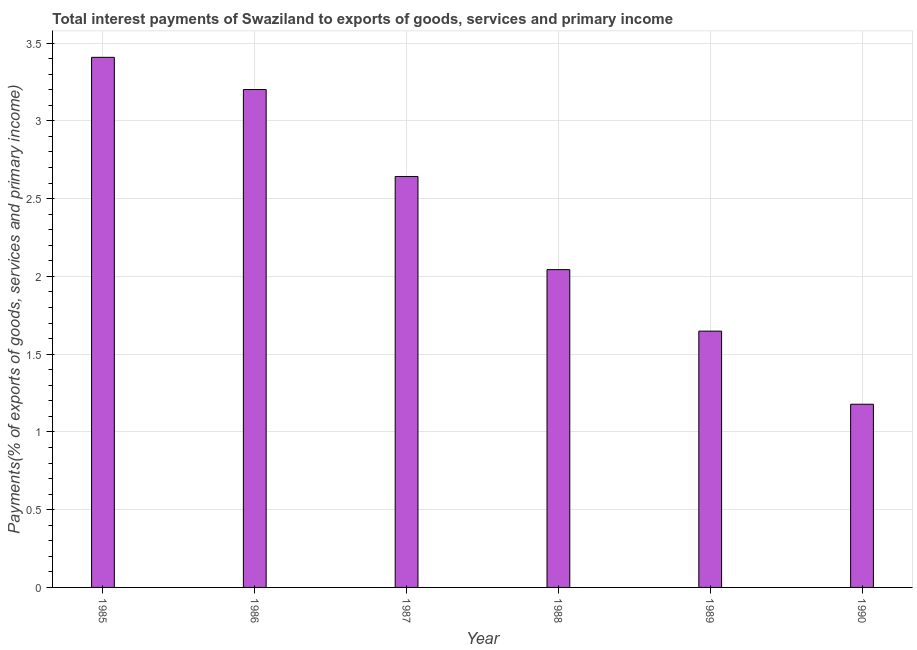What is the title of the graph?
Provide a short and direct response. Total interest payments of Swaziland to exports of goods, services and primary income. What is the label or title of the X-axis?
Offer a terse response. Year. What is the label or title of the Y-axis?
Provide a succinct answer. Payments(% of exports of goods, services and primary income). What is the total interest payments on external debt in 1985?
Provide a succinct answer. 3.41. Across all years, what is the maximum total interest payments on external debt?
Offer a terse response. 3.41. Across all years, what is the minimum total interest payments on external debt?
Your response must be concise. 1.18. In which year was the total interest payments on external debt minimum?
Your answer should be compact. 1990. What is the sum of the total interest payments on external debt?
Offer a terse response. 14.12. What is the difference between the total interest payments on external debt in 1988 and 1989?
Offer a very short reply. 0.4. What is the average total interest payments on external debt per year?
Your answer should be very brief. 2.35. What is the median total interest payments on external debt?
Ensure brevity in your answer.  2.34. What is the ratio of the total interest payments on external debt in 1987 to that in 1990?
Your response must be concise. 2.24. Is the total interest payments on external debt in 1986 less than that in 1988?
Offer a terse response. No. What is the difference between the highest and the second highest total interest payments on external debt?
Keep it short and to the point. 0.21. What is the difference between the highest and the lowest total interest payments on external debt?
Offer a very short reply. 2.23. In how many years, is the total interest payments on external debt greater than the average total interest payments on external debt taken over all years?
Keep it short and to the point. 3. How many bars are there?
Offer a very short reply. 6. Are all the bars in the graph horizontal?
Your answer should be compact. No. What is the Payments(% of exports of goods, services and primary income) of 1985?
Keep it short and to the point. 3.41. What is the Payments(% of exports of goods, services and primary income) in 1986?
Your answer should be very brief. 3.2. What is the Payments(% of exports of goods, services and primary income) of 1987?
Offer a terse response. 2.64. What is the Payments(% of exports of goods, services and primary income) of 1988?
Your answer should be very brief. 2.04. What is the Payments(% of exports of goods, services and primary income) of 1989?
Make the answer very short. 1.65. What is the Payments(% of exports of goods, services and primary income) of 1990?
Offer a very short reply. 1.18. What is the difference between the Payments(% of exports of goods, services and primary income) in 1985 and 1986?
Offer a very short reply. 0.21. What is the difference between the Payments(% of exports of goods, services and primary income) in 1985 and 1987?
Ensure brevity in your answer.  0.77. What is the difference between the Payments(% of exports of goods, services and primary income) in 1985 and 1988?
Ensure brevity in your answer.  1.37. What is the difference between the Payments(% of exports of goods, services and primary income) in 1985 and 1989?
Keep it short and to the point. 1.76. What is the difference between the Payments(% of exports of goods, services and primary income) in 1985 and 1990?
Offer a very short reply. 2.23. What is the difference between the Payments(% of exports of goods, services and primary income) in 1986 and 1987?
Offer a very short reply. 0.56. What is the difference between the Payments(% of exports of goods, services and primary income) in 1986 and 1988?
Your answer should be very brief. 1.16. What is the difference between the Payments(% of exports of goods, services and primary income) in 1986 and 1989?
Offer a terse response. 1.55. What is the difference between the Payments(% of exports of goods, services and primary income) in 1986 and 1990?
Provide a succinct answer. 2.02. What is the difference between the Payments(% of exports of goods, services and primary income) in 1987 and 1988?
Offer a very short reply. 0.6. What is the difference between the Payments(% of exports of goods, services and primary income) in 1987 and 1989?
Offer a very short reply. 0.99. What is the difference between the Payments(% of exports of goods, services and primary income) in 1987 and 1990?
Provide a short and direct response. 1.46. What is the difference between the Payments(% of exports of goods, services and primary income) in 1988 and 1989?
Keep it short and to the point. 0.4. What is the difference between the Payments(% of exports of goods, services and primary income) in 1988 and 1990?
Ensure brevity in your answer.  0.87. What is the difference between the Payments(% of exports of goods, services and primary income) in 1989 and 1990?
Offer a terse response. 0.47. What is the ratio of the Payments(% of exports of goods, services and primary income) in 1985 to that in 1986?
Your answer should be very brief. 1.06. What is the ratio of the Payments(% of exports of goods, services and primary income) in 1985 to that in 1987?
Give a very brief answer. 1.29. What is the ratio of the Payments(% of exports of goods, services and primary income) in 1985 to that in 1988?
Your response must be concise. 1.67. What is the ratio of the Payments(% of exports of goods, services and primary income) in 1985 to that in 1989?
Your answer should be very brief. 2.07. What is the ratio of the Payments(% of exports of goods, services and primary income) in 1985 to that in 1990?
Your answer should be very brief. 2.89. What is the ratio of the Payments(% of exports of goods, services and primary income) in 1986 to that in 1987?
Keep it short and to the point. 1.21. What is the ratio of the Payments(% of exports of goods, services and primary income) in 1986 to that in 1988?
Your answer should be compact. 1.57. What is the ratio of the Payments(% of exports of goods, services and primary income) in 1986 to that in 1989?
Your response must be concise. 1.94. What is the ratio of the Payments(% of exports of goods, services and primary income) in 1986 to that in 1990?
Offer a terse response. 2.72. What is the ratio of the Payments(% of exports of goods, services and primary income) in 1987 to that in 1988?
Provide a short and direct response. 1.29. What is the ratio of the Payments(% of exports of goods, services and primary income) in 1987 to that in 1989?
Your answer should be very brief. 1.6. What is the ratio of the Payments(% of exports of goods, services and primary income) in 1987 to that in 1990?
Provide a succinct answer. 2.24. What is the ratio of the Payments(% of exports of goods, services and primary income) in 1988 to that in 1989?
Ensure brevity in your answer.  1.24. What is the ratio of the Payments(% of exports of goods, services and primary income) in 1988 to that in 1990?
Offer a terse response. 1.74. What is the ratio of the Payments(% of exports of goods, services and primary income) in 1989 to that in 1990?
Your answer should be compact. 1.4. 